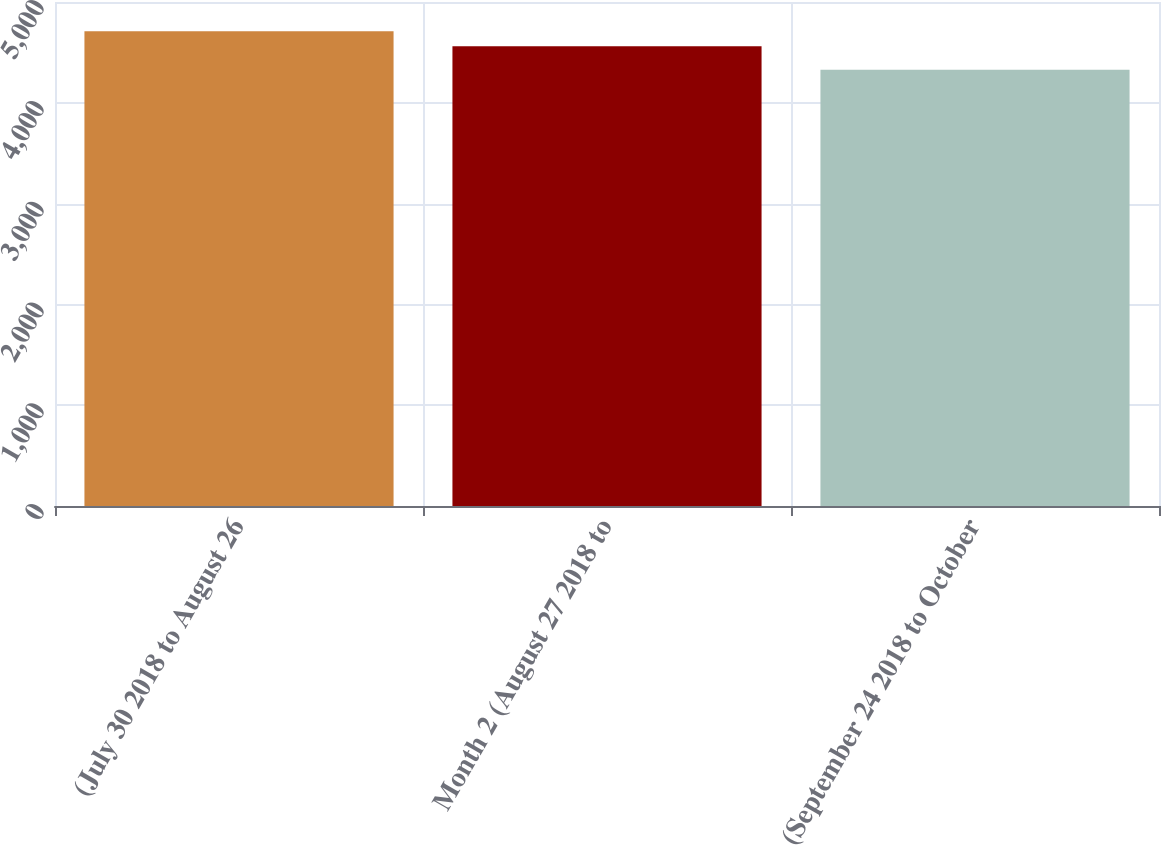<chart> <loc_0><loc_0><loc_500><loc_500><bar_chart><fcel>(July 30 2018 to August 26<fcel>Month 2 (August 27 2018 to<fcel>(September 24 2018 to October<nl><fcel>4709<fcel>4561<fcel>4327<nl></chart> 